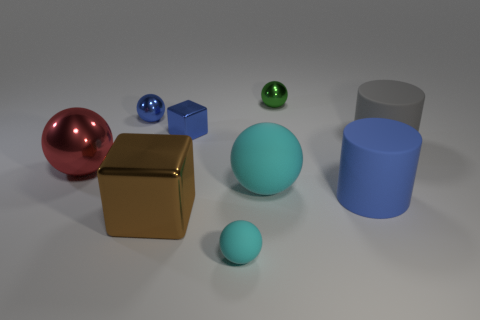Subtract all red cylinders. How many cyan balls are left? 2 Subtract all tiny cyan rubber spheres. How many spheres are left? 4 Subtract all red spheres. How many spheres are left? 4 Subtract all cubes. How many objects are left? 7 Subtract all cyan spheres. Subtract all red cylinders. How many spheres are left? 3 Add 3 tiny metallic spheres. How many tiny metallic spheres exist? 5 Subtract 1 blue cylinders. How many objects are left? 8 Subtract all large blue objects. Subtract all green spheres. How many objects are left? 7 Add 6 small cyan matte spheres. How many small cyan matte spheres are left? 7 